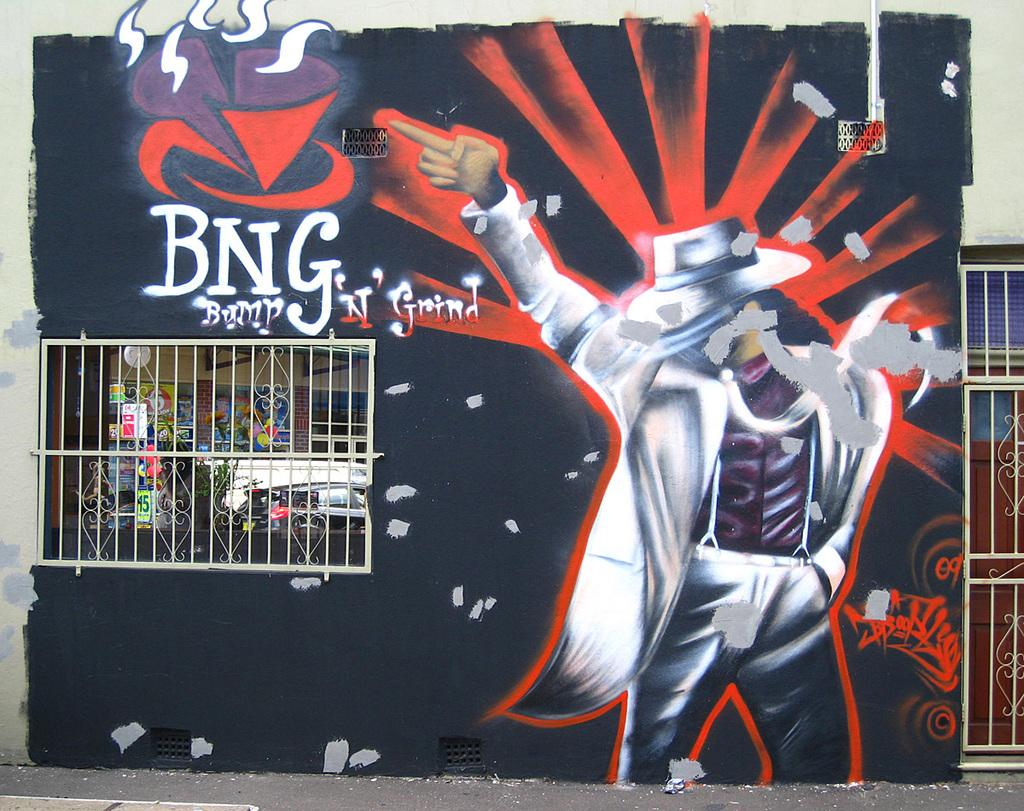<image>
Give a short and clear explanation of the subsequent image. A mural of a man who looks like Michael Jackson contains the writing "BNG Bump N' Grind". 